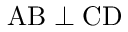Convert formula to latex. <formula><loc_0><loc_0><loc_500><loc_500>A B \perp C D</formula> 